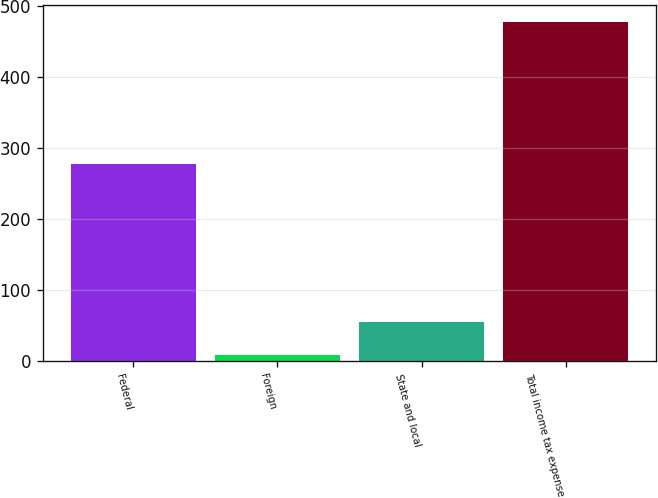Convert chart to OTSL. <chart><loc_0><loc_0><loc_500><loc_500><bar_chart><fcel>Federal<fcel>Foreign<fcel>State and local<fcel>Total income tax expense<nl><fcel>277.9<fcel>7.9<fcel>54.87<fcel>477.6<nl></chart> 